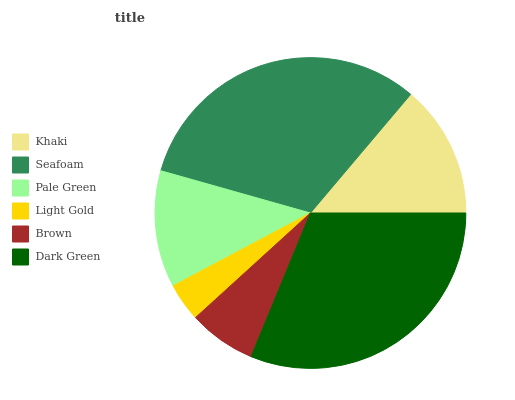Is Light Gold the minimum?
Answer yes or no. Yes. Is Seafoam the maximum?
Answer yes or no. Yes. Is Pale Green the minimum?
Answer yes or no. No. Is Pale Green the maximum?
Answer yes or no. No. Is Seafoam greater than Pale Green?
Answer yes or no. Yes. Is Pale Green less than Seafoam?
Answer yes or no. Yes. Is Pale Green greater than Seafoam?
Answer yes or no. No. Is Seafoam less than Pale Green?
Answer yes or no. No. Is Khaki the high median?
Answer yes or no. Yes. Is Pale Green the low median?
Answer yes or no. Yes. Is Dark Green the high median?
Answer yes or no. No. Is Khaki the low median?
Answer yes or no. No. 